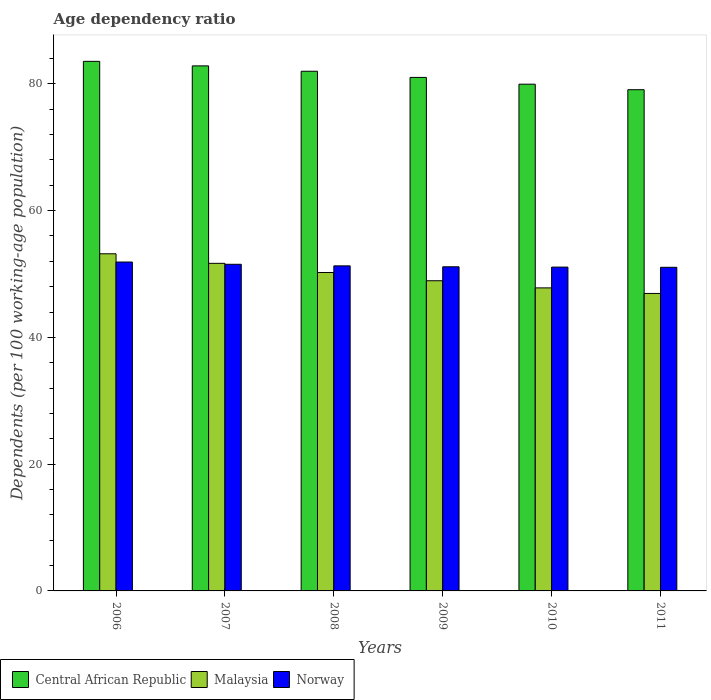How many groups of bars are there?
Keep it short and to the point. 6. Are the number of bars per tick equal to the number of legend labels?
Keep it short and to the point. Yes. Are the number of bars on each tick of the X-axis equal?
Your answer should be very brief. Yes. What is the label of the 3rd group of bars from the left?
Your answer should be very brief. 2008. In how many cases, is the number of bars for a given year not equal to the number of legend labels?
Ensure brevity in your answer.  0. What is the age dependency ratio in in Central African Republic in 2010?
Your answer should be very brief. 79.95. Across all years, what is the maximum age dependency ratio in in Central African Republic?
Ensure brevity in your answer.  83.55. Across all years, what is the minimum age dependency ratio in in Central African Republic?
Your answer should be compact. 79.08. In which year was the age dependency ratio in in Norway minimum?
Offer a terse response. 2011. What is the total age dependency ratio in in Norway in the graph?
Offer a very short reply. 307.99. What is the difference between the age dependency ratio in in Norway in 2009 and that in 2010?
Your answer should be compact. 0.05. What is the difference between the age dependency ratio in in Malaysia in 2007 and the age dependency ratio in in Central African Republic in 2006?
Ensure brevity in your answer.  -31.87. What is the average age dependency ratio in in Central African Republic per year?
Offer a very short reply. 81.4. In the year 2010, what is the difference between the age dependency ratio in in Central African Republic and age dependency ratio in in Malaysia?
Make the answer very short. 32.14. What is the ratio of the age dependency ratio in in Malaysia in 2009 to that in 2010?
Offer a very short reply. 1.02. Is the age dependency ratio in in Malaysia in 2006 less than that in 2010?
Offer a very short reply. No. Is the difference between the age dependency ratio in in Central African Republic in 2006 and 2008 greater than the difference between the age dependency ratio in in Malaysia in 2006 and 2008?
Ensure brevity in your answer.  No. What is the difference between the highest and the second highest age dependency ratio in in Malaysia?
Your answer should be very brief. 1.51. What is the difference between the highest and the lowest age dependency ratio in in Central African Republic?
Keep it short and to the point. 4.47. In how many years, is the age dependency ratio in in Malaysia greater than the average age dependency ratio in in Malaysia taken over all years?
Give a very brief answer. 3. Is the sum of the age dependency ratio in in Norway in 2007 and 2011 greater than the maximum age dependency ratio in in Central African Republic across all years?
Provide a succinct answer. Yes. What does the 3rd bar from the left in 2008 represents?
Give a very brief answer. Norway. What does the 2nd bar from the right in 2006 represents?
Ensure brevity in your answer.  Malaysia. How many bars are there?
Give a very brief answer. 18. How many years are there in the graph?
Keep it short and to the point. 6. What is the difference between two consecutive major ticks on the Y-axis?
Offer a very short reply. 20. Does the graph contain any zero values?
Offer a terse response. No. Does the graph contain grids?
Provide a succinct answer. No. How many legend labels are there?
Ensure brevity in your answer.  3. How are the legend labels stacked?
Your answer should be very brief. Horizontal. What is the title of the graph?
Offer a very short reply. Age dependency ratio. What is the label or title of the Y-axis?
Your response must be concise. Dependents (per 100 working-age population). What is the Dependents (per 100 working-age population) in Central African Republic in 2006?
Your answer should be compact. 83.55. What is the Dependents (per 100 working-age population) of Malaysia in 2006?
Ensure brevity in your answer.  53.19. What is the Dependents (per 100 working-age population) of Norway in 2006?
Your answer should be very brief. 51.89. What is the Dependents (per 100 working-age population) of Central African Republic in 2007?
Your response must be concise. 82.84. What is the Dependents (per 100 working-age population) in Malaysia in 2007?
Offer a terse response. 51.68. What is the Dependents (per 100 working-age population) in Norway in 2007?
Make the answer very short. 51.53. What is the Dependents (per 100 working-age population) in Central African Republic in 2008?
Your answer should be compact. 81.99. What is the Dependents (per 100 working-age population) of Malaysia in 2008?
Make the answer very short. 50.23. What is the Dependents (per 100 working-age population) of Norway in 2008?
Keep it short and to the point. 51.28. What is the Dependents (per 100 working-age population) of Central African Republic in 2009?
Offer a terse response. 81.02. What is the Dependents (per 100 working-age population) in Malaysia in 2009?
Keep it short and to the point. 48.94. What is the Dependents (per 100 working-age population) of Norway in 2009?
Offer a terse response. 51.14. What is the Dependents (per 100 working-age population) in Central African Republic in 2010?
Give a very brief answer. 79.95. What is the Dependents (per 100 working-age population) in Malaysia in 2010?
Provide a short and direct response. 47.81. What is the Dependents (per 100 working-age population) of Norway in 2010?
Offer a very short reply. 51.09. What is the Dependents (per 100 working-age population) in Central African Republic in 2011?
Give a very brief answer. 79.08. What is the Dependents (per 100 working-age population) of Malaysia in 2011?
Give a very brief answer. 46.93. What is the Dependents (per 100 working-age population) in Norway in 2011?
Give a very brief answer. 51.06. Across all years, what is the maximum Dependents (per 100 working-age population) in Central African Republic?
Offer a terse response. 83.55. Across all years, what is the maximum Dependents (per 100 working-age population) in Malaysia?
Provide a succinct answer. 53.19. Across all years, what is the maximum Dependents (per 100 working-age population) of Norway?
Make the answer very short. 51.89. Across all years, what is the minimum Dependents (per 100 working-age population) in Central African Republic?
Make the answer very short. 79.08. Across all years, what is the minimum Dependents (per 100 working-age population) in Malaysia?
Offer a terse response. 46.93. Across all years, what is the minimum Dependents (per 100 working-age population) in Norway?
Your response must be concise. 51.06. What is the total Dependents (per 100 working-age population) in Central African Republic in the graph?
Provide a short and direct response. 488.42. What is the total Dependents (per 100 working-age population) in Malaysia in the graph?
Ensure brevity in your answer.  298.79. What is the total Dependents (per 100 working-age population) of Norway in the graph?
Keep it short and to the point. 307.99. What is the difference between the Dependents (per 100 working-age population) in Central African Republic in 2006 and that in 2007?
Keep it short and to the point. 0.71. What is the difference between the Dependents (per 100 working-age population) in Malaysia in 2006 and that in 2007?
Make the answer very short. 1.51. What is the difference between the Dependents (per 100 working-age population) in Norway in 2006 and that in 2007?
Make the answer very short. 0.36. What is the difference between the Dependents (per 100 working-age population) in Central African Republic in 2006 and that in 2008?
Give a very brief answer. 1.56. What is the difference between the Dependents (per 100 working-age population) in Malaysia in 2006 and that in 2008?
Provide a short and direct response. 2.96. What is the difference between the Dependents (per 100 working-age population) in Norway in 2006 and that in 2008?
Make the answer very short. 0.61. What is the difference between the Dependents (per 100 working-age population) in Central African Republic in 2006 and that in 2009?
Your answer should be compact. 2.53. What is the difference between the Dependents (per 100 working-age population) in Malaysia in 2006 and that in 2009?
Your answer should be compact. 4.25. What is the difference between the Dependents (per 100 working-age population) in Norway in 2006 and that in 2009?
Make the answer very short. 0.75. What is the difference between the Dependents (per 100 working-age population) in Central African Republic in 2006 and that in 2010?
Provide a succinct answer. 3.6. What is the difference between the Dependents (per 100 working-age population) of Malaysia in 2006 and that in 2010?
Your response must be concise. 5.38. What is the difference between the Dependents (per 100 working-age population) in Norway in 2006 and that in 2010?
Ensure brevity in your answer.  0.8. What is the difference between the Dependents (per 100 working-age population) in Central African Republic in 2006 and that in 2011?
Offer a terse response. 4.47. What is the difference between the Dependents (per 100 working-age population) in Malaysia in 2006 and that in 2011?
Give a very brief answer. 6.26. What is the difference between the Dependents (per 100 working-age population) in Norway in 2006 and that in 2011?
Give a very brief answer. 0.83. What is the difference between the Dependents (per 100 working-age population) in Central African Republic in 2007 and that in 2008?
Your response must be concise. 0.85. What is the difference between the Dependents (per 100 working-age population) of Malaysia in 2007 and that in 2008?
Offer a terse response. 1.45. What is the difference between the Dependents (per 100 working-age population) of Norway in 2007 and that in 2008?
Your response must be concise. 0.25. What is the difference between the Dependents (per 100 working-age population) in Central African Republic in 2007 and that in 2009?
Ensure brevity in your answer.  1.82. What is the difference between the Dependents (per 100 working-age population) in Malaysia in 2007 and that in 2009?
Provide a short and direct response. 2.75. What is the difference between the Dependents (per 100 working-age population) in Norway in 2007 and that in 2009?
Make the answer very short. 0.39. What is the difference between the Dependents (per 100 working-age population) in Central African Republic in 2007 and that in 2010?
Your answer should be compact. 2.89. What is the difference between the Dependents (per 100 working-age population) of Malaysia in 2007 and that in 2010?
Your response must be concise. 3.87. What is the difference between the Dependents (per 100 working-age population) of Norway in 2007 and that in 2010?
Offer a terse response. 0.44. What is the difference between the Dependents (per 100 working-age population) in Central African Republic in 2007 and that in 2011?
Provide a succinct answer. 3.76. What is the difference between the Dependents (per 100 working-age population) in Malaysia in 2007 and that in 2011?
Provide a succinct answer. 4.75. What is the difference between the Dependents (per 100 working-age population) in Norway in 2007 and that in 2011?
Provide a succinct answer. 0.48. What is the difference between the Dependents (per 100 working-age population) of Central African Republic in 2008 and that in 2009?
Your answer should be very brief. 0.97. What is the difference between the Dependents (per 100 working-age population) of Malaysia in 2008 and that in 2009?
Ensure brevity in your answer.  1.3. What is the difference between the Dependents (per 100 working-age population) of Norway in 2008 and that in 2009?
Ensure brevity in your answer.  0.15. What is the difference between the Dependents (per 100 working-age population) in Central African Republic in 2008 and that in 2010?
Provide a succinct answer. 2.04. What is the difference between the Dependents (per 100 working-age population) in Malaysia in 2008 and that in 2010?
Give a very brief answer. 2.42. What is the difference between the Dependents (per 100 working-age population) of Norway in 2008 and that in 2010?
Your answer should be very brief. 0.19. What is the difference between the Dependents (per 100 working-age population) of Central African Republic in 2008 and that in 2011?
Make the answer very short. 2.91. What is the difference between the Dependents (per 100 working-age population) of Malaysia in 2008 and that in 2011?
Your answer should be compact. 3.3. What is the difference between the Dependents (per 100 working-age population) of Norway in 2008 and that in 2011?
Provide a succinct answer. 0.23. What is the difference between the Dependents (per 100 working-age population) of Central African Republic in 2009 and that in 2010?
Provide a succinct answer. 1.07. What is the difference between the Dependents (per 100 working-age population) of Malaysia in 2009 and that in 2010?
Give a very brief answer. 1.13. What is the difference between the Dependents (per 100 working-age population) in Norway in 2009 and that in 2010?
Offer a very short reply. 0.05. What is the difference between the Dependents (per 100 working-age population) of Central African Republic in 2009 and that in 2011?
Provide a short and direct response. 1.94. What is the difference between the Dependents (per 100 working-age population) in Malaysia in 2009 and that in 2011?
Provide a succinct answer. 2. What is the difference between the Dependents (per 100 working-age population) in Norway in 2009 and that in 2011?
Give a very brief answer. 0.08. What is the difference between the Dependents (per 100 working-age population) of Central African Republic in 2010 and that in 2011?
Provide a succinct answer. 0.87. What is the difference between the Dependents (per 100 working-age population) in Malaysia in 2010 and that in 2011?
Keep it short and to the point. 0.88. What is the difference between the Dependents (per 100 working-age population) in Norway in 2010 and that in 2011?
Ensure brevity in your answer.  0.03. What is the difference between the Dependents (per 100 working-age population) in Central African Republic in 2006 and the Dependents (per 100 working-age population) in Malaysia in 2007?
Give a very brief answer. 31.87. What is the difference between the Dependents (per 100 working-age population) of Central African Republic in 2006 and the Dependents (per 100 working-age population) of Norway in 2007?
Provide a succinct answer. 32.02. What is the difference between the Dependents (per 100 working-age population) in Malaysia in 2006 and the Dependents (per 100 working-age population) in Norway in 2007?
Provide a succinct answer. 1.66. What is the difference between the Dependents (per 100 working-age population) of Central African Republic in 2006 and the Dependents (per 100 working-age population) of Malaysia in 2008?
Your answer should be compact. 33.32. What is the difference between the Dependents (per 100 working-age population) of Central African Republic in 2006 and the Dependents (per 100 working-age population) of Norway in 2008?
Ensure brevity in your answer.  32.27. What is the difference between the Dependents (per 100 working-age population) in Malaysia in 2006 and the Dependents (per 100 working-age population) in Norway in 2008?
Make the answer very short. 1.91. What is the difference between the Dependents (per 100 working-age population) in Central African Republic in 2006 and the Dependents (per 100 working-age population) in Malaysia in 2009?
Ensure brevity in your answer.  34.61. What is the difference between the Dependents (per 100 working-age population) in Central African Republic in 2006 and the Dependents (per 100 working-age population) in Norway in 2009?
Your answer should be compact. 32.41. What is the difference between the Dependents (per 100 working-age population) of Malaysia in 2006 and the Dependents (per 100 working-age population) of Norway in 2009?
Make the answer very short. 2.05. What is the difference between the Dependents (per 100 working-age population) of Central African Republic in 2006 and the Dependents (per 100 working-age population) of Malaysia in 2010?
Ensure brevity in your answer.  35.74. What is the difference between the Dependents (per 100 working-age population) of Central African Republic in 2006 and the Dependents (per 100 working-age population) of Norway in 2010?
Your answer should be very brief. 32.46. What is the difference between the Dependents (per 100 working-age population) in Malaysia in 2006 and the Dependents (per 100 working-age population) in Norway in 2010?
Make the answer very short. 2.1. What is the difference between the Dependents (per 100 working-age population) in Central African Republic in 2006 and the Dependents (per 100 working-age population) in Malaysia in 2011?
Keep it short and to the point. 36.62. What is the difference between the Dependents (per 100 working-age population) in Central African Republic in 2006 and the Dependents (per 100 working-age population) in Norway in 2011?
Give a very brief answer. 32.49. What is the difference between the Dependents (per 100 working-age population) of Malaysia in 2006 and the Dependents (per 100 working-age population) of Norway in 2011?
Provide a succinct answer. 2.13. What is the difference between the Dependents (per 100 working-age population) in Central African Republic in 2007 and the Dependents (per 100 working-age population) in Malaysia in 2008?
Ensure brevity in your answer.  32.6. What is the difference between the Dependents (per 100 working-age population) of Central African Republic in 2007 and the Dependents (per 100 working-age population) of Norway in 2008?
Offer a very short reply. 31.55. What is the difference between the Dependents (per 100 working-age population) of Malaysia in 2007 and the Dependents (per 100 working-age population) of Norway in 2008?
Provide a succinct answer. 0.4. What is the difference between the Dependents (per 100 working-age population) in Central African Republic in 2007 and the Dependents (per 100 working-age population) in Malaysia in 2009?
Ensure brevity in your answer.  33.9. What is the difference between the Dependents (per 100 working-age population) of Central African Republic in 2007 and the Dependents (per 100 working-age population) of Norway in 2009?
Make the answer very short. 31.7. What is the difference between the Dependents (per 100 working-age population) of Malaysia in 2007 and the Dependents (per 100 working-age population) of Norway in 2009?
Offer a very short reply. 0.55. What is the difference between the Dependents (per 100 working-age population) of Central African Republic in 2007 and the Dependents (per 100 working-age population) of Malaysia in 2010?
Your response must be concise. 35.03. What is the difference between the Dependents (per 100 working-age population) of Central African Republic in 2007 and the Dependents (per 100 working-age population) of Norway in 2010?
Provide a short and direct response. 31.75. What is the difference between the Dependents (per 100 working-age population) in Malaysia in 2007 and the Dependents (per 100 working-age population) in Norway in 2010?
Keep it short and to the point. 0.59. What is the difference between the Dependents (per 100 working-age population) in Central African Republic in 2007 and the Dependents (per 100 working-age population) in Malaysia in 2011?
Make the answer very short. 35.9. What is the difference between the Dependents (per 100 working-age population) in Central African Republic in 2007 and the Dependents (per 100 working-age population) in Norway in 2011?
Offer a very short reply. 31.78. What is the difference between the Dependents (per 100 working-age population) in Malaysia in 2007 and the Dependents (per 100 working-age population) in Norway in 2011?
Your answer should be very brief. 0.63. What is the difference between the Dependents (per 100 working-age population) of Central African Republic in 2008 and the Dependents (per 100 working-age population) of Malaysia in 2009?
Give a very brief answer. 33.05. What is the difference between the Dependents (per 100 working-age population) in Central African Republic in 2008 and the Dependents (per 100 working-age population) in Norway in 2009?
Provide a short and direct response. 30.85. What is the difference between the Dependents (per 100 working-age population) in Malaysia in 2008 and the Dependents (per 100 working-age population) in Norway in 2009?
Your response must be concise. -0.9. What is the difference between the Dependents (per 100 working-age population) in Central African Republic in 2008 and the Dependents (per 100 working-age population) in Malaysia in 2010?
Provide a short and direct response. 34.18. What is the difference between the Dependents (per 100 working-age population) of Central African Republic in 2008 and the Dependents (per 100 working-age population) of Norway in 2010?
Provide a succinct answer. 30.9. What is the difference between the Dependents (per 100 working-age population) in Malaysia in 2008 and the Dependents (per 100 working-age population) in Norway in 2010?
Offer a very short reply. -0.86. What is the difference between the Dependents (per 100 working-age population) in Central African Republic in 2008 and the Dependents (per 100 working-age population) in Malaysia in 2011?
Give a very brief answer. 35.06. What is the difference between the Dependents (per 100 working-age population) of Central African Republic in 2008 and the Dependents (per 100 working-age population) of Norway in 2011?
Your answer should be very brief. 30.93. What is the difference between the Dependents (per 100 working-age population) in Malaysia in 2008 and the Dependents (per 100 working-age population) in Norway in 2011?
Your answer should be compact. -0.82. What is the difference between the Dependents (per 100 working-age population) in Central African Republic in 2009 and the Dependents (per 100 working-age population) in Malaysia in 2010?
Keep it short and to the point. 33.21. What is the difference between the Dependents (per 100 working-age population) in Central African Republic in 2009 and the Dependents (per 100 working-age population) in Norway in 2010?
Give a very brief answer. 29.93. What is the difference between the Dependents (per 100 working-age population) of Malaysia in 2009 and the Dependents (per 100 working-age population) of Norway in 2010?
Provide a succinct answer. -2.15. What is the difference between the Dependents (per 100 working-age population) in Central African Republic in 2009 and the Dependents (per 100 working-age population) in Malaysia in 2011?
Keep it short and to the point. 34.08. What is the difference between the Dependents (per 100 working-age population) of Central African Republic in 2009 and the Dependents (per 100 working-age population) of Norway in 2011?
Offer a very short reply. 29.96. What is the difference between the Dependents (per 100 working-age population) in Malaysia in 2009 and the Dependents (per 100 working-age population) in Norway in 2011?
Provide a succinct answer. -2.12. What is the difference between the Dependents (per 100 working-age population) in Central African Republic in 2010 and the Dependents (per 100 working-age population) in Malaysia in 2011?
Provide a short and direct response. 33.02. What is the difference between the Dependents (per 100 working-age population) of Central African Republic in 2010 and the Dependents (per 100 working-age population) of Norway in 2011?
Ensure brevity in your answer.  28.89. What is the difference between the Dependents (per 100 working-age population) in Malaysia in 2010 and the Dependents (per 100 working-age population) in Norway in 2011?
Ensure brevity in your answer.  -3.25. What is the average Dependents (per 100 working-age population) of Central African Republic per year?
Give a very brief answer. 81.4. What is the average Dependents (per 100 working-age population) in Malaysia per year?
Your answer should be compact. 49.8. What is the average Dependents (per 100 working-age population) in Norway per year?
Keep it short and to the point. 51.33. In the year 2006, what is the difference between the Dependents (per 100 working-age population) of Central African Republic and Dependents (per 100 working-age population) of Malaysia?
Your answer should be compact. 30.36. In the year 2006, what is the difference between the Dependents (per 100 working-age population) of Central African Republic and Dependents (per 100 working-age population) of Norway?
Provide a succinct answer. 31.66. In the year 2006, what is the difference between the Dependents (per 100 working-age population) in Malaysia and Dependents (per 100 working-age population) in Norway?
Provide a short and direct response. 1.3. In the year 2007, what is the difference between the Dependents (per 100 working-age population) in Central African Republic and Dependents (per 100 working-age population) in Malaysia?
Provide a short and direct response. 31.15. In the year 2007, what is the difference between the Dependents (per 100 working-age population) of Central African Republic and Dependents (per 100 working-age population) of Norway?
Provide a succinct answer. 31.3. In the year 2007, what is the difference between the Dependents (per 100 working-age population) of Malaysia and Dependents (per 100 working-age population) of Norway?
Provide a succinct answer. 0.15. In the year 2008, what is the difference between the Dependents (per 100 working-age population) in Central African Republic and Dependents (per 100 working-age population) in Malaysia?
Offer a terse response. 31.75. In the year 2008, what is the difference between the Dependents (per 100 working-age population) of Central African Republic and Dependents (per 100 working-age population) of Norway?
Keep it short and to the point. 30.7. In the year 2008, what is the difference between the Dependents (per 100 working-age population) in Malaysia and Dependents (per 100 working-age population) in Norway?
Ensure brevity in your answer.  -1.05. In the year 2009, what is the difference between the Dependents (per 100 working-age population) of Central African Republic and Dependents (per 100 working-age population) of Malaysia?
Ensure brevity in your answer.  32.08. In the year 2009, what is the difference between the Dependents (per 100 working-age population) in Central African Republic and Dependents (per 100 working-age population) in Norway?
Your answer should be very brief. 29.88. In the year 2009, what is the difference between the Dependents (per 100 working-age population) in Malaysia and Dependents (per 100 working-age population) in Norway?
Ensure brevity in your answer.  -2.2. In the year 2010, what is the difference between the Dependents (per 100 working-age population) of Central African Republic and Dependents (per 100 working-age population) of Malaysia?
Keep it short and to the point. 32.14. In the year 2010, what is the difference between the Dependents (per 100 working-age population) in Central African Republic and Dependents (per 100 working-age population) in Norway?
Give a very brief answer. 28.86. In the year 2010, what is the difference between the Dependents (per 100 working-age population) of Malaysia and Dependents (per 100 working-age population) of Norway?
Ensure brevity in your answer.  -3.28. In the year 2011, what is the difference between the Dependents (per 100 working-age population) of Central African Republic and Dependents (per 100 working-age population) of Malaysia?
Your response must be concise. 32.14. In the year 2011, what is the difference between the Dependents (per 100 working-age population) of Central African Republic and Dependents (per 100 working-age population) of Norway?
Make the answer very short. 28.02. In the year 2011, what is the difference between the Dependents (per 100 working-age population) of Malaysia and Dependents (per 100 working-age population) of Norway?
Give a very brief answer. -4.12. What is the ratio of the Dependents (per 100 working-age population) in Central African Republic in 2006 to that in 2007?
Your response must be concise. 1.01. What is the ratio of the Dependents (per 100 working-age population) of Malaysia in 2006 to that in 2007?
Offer a terse response. 1.03. What is the ratio of the Dependents (per 100 working-age population) of Norway in 2006 to that in 2007?
Your answer should be compact. 1.01. What is the ratio of the Dependents (per 100 working-age population) of Central African Republic in 2006 to that in 2008?
Give a very brief answer. 1.02. What is the ratio of the Dependents (per 100 working-age population) in Malaysia in 2006 to that in 2008?
Offer a very short reply. 1.06. What is the ratio of the Dependents (per 100 working-age population) of Norway in 2006 to that in 2008?
Provide a short and direct response. 1.01. What is the ratio of the Dependents (per 100 working-age population) of Central African Republic in 2006 to that in 2009?
Provide a succinct answer. 1.03. What is the ratio of the Dependents (per 100 working-age population) of Malaysia in 2006 to that in 2009?
Your answer should be very brief. 1.09. What is the ratio of the Dependents (per 100 working-age population) of Norway in 2006 to that in 2009?
Offer a terse response. 1.01. What is the ratio of the Dependents (per 100 working-age population) in Central African Republic in 2006 to that in 2010?
Offer a terse response. 1.04. What is the ratio of the Dependents (per 100 working-age population) in Malaysia in 2006 to that in 2010?
Make the answer very short. 1.11. What is the ratio of the Dependents (per 100 working-age population) of Norway in 2006 to that in 2010?
Offer a very short reply. 1.02. What is the ratio of the Dependents (per 100 working-age population) of Central African Republic in 2006 to that in 2011?
Provide a short and direct response. 1.06. What is the ratio of the Dependents (per 100 working-age population) of Malaysia in 2006 to that in 2011?
Your answer should be very brief. 1.13. What is the ratio of the Dependents (per 100 working-age population) in Norway in 2006 to that in 2011?
Provide a succinct answer. 1.02. What is the ratio of the Dependents (per 100 working-age population) in Central African Republic in 2007 to that in 2008?
Provide a short and direct response. 1.01. What is the ratio of the Dependents (per 100 working-age population) of Malaysia in 2007 to that in 2008?
Provide a succinct answer. 1.03. What is the ratio of the Dependents (per 100 working-age population) in Central African Republic in 2007 to that in 2009?
Provide a short and direct response. 1.02. What is the ratio of the Dependents (per 100 working-age population) of Malaysia in 2007 to that in 2009?
Your answer should be very brief. 1.06. What is the ratio of the Dependents (per 100 working-age population) in Norway in 2007 to that in 2009?
Provide a succinct answer. 1.01. What is the ratio of the Dependents (per 100 working-age population) in Central African Republic in 2007 to that in 2010?
Your response must be concise. 1.04. What is the ratio of the Dependents (per 100 working-age population) in Malaysia in 2007 to that in 2010?
Give a very brief answer. 1.08. What is the ratio of the Dependents (per 100 working-age population) in Norway in 2007 to that in 2010?
Ensure brevity in your answer.  1.01. What is the ratio of the Dependents (per 100 working-age population) of Central African Republic in 2007 to that in 2011?
Your answer should be compact. 1.05. What is the ratio of the Dependents (per 100 working-age population) in Malaysia in 2007 to that in 2011?
Offer a very short reply. 1.1. What is the ratio of the Dependents (per 100 working-age population) of Norway in 2007 to that in 2011?
Give a very brief answer. 1.01. What is the ratio of the Dependents (per 100 working-age population) in Malaysia in 2008 to that in 2009?
Keep it short and to the point. 1.03. What is the ratio of the Dependents (per 100 working-age population) of Central African Republic in 2008 to that in 2010?
Your answer should be compact. 1.03. What is the ratio of the Dependents (per 100 working-age population) in Malaysia in 2008 to that in 2010?
Your answer should be compact. 1.05. What is the ratio of the Dependents (per 100 working-age population) of Norway in 2008 to that in 2010?
Your answer should be very brief. 1. What is the ratio of the Dependents (per 100 working-age population) in Central African Republic in 2008 to that in 2011?
Offer a very short reply. 1.04. What is the ratio of the Dependents (per 100 working-age population) in Malaysia in 2008 to that in 2011?
Provide a short and direct response. 1.07. What is the ratio of the Dependents (per 100 working-age population) in Norway in 2008 to that in 2011?
Your answer should be compact. 1. What is the ratio of the Dependents (per 100 working-age population) in Central African Republic in 2009 to that in 2010?
Provide a succinct answer. 1.01. What is the ratio of the Dependents (per 100 working-age population) in Malaysia in 2009 to that in 2010?
Ensure brevity in your answer.  1.02. What is the ratio of the Dependents (per 100 working-age population) in Norway in 2009 to that in 2010?
Offer a terse response. 1. What is the ratio of the Dependents (per 100 working-age population) of Central African Republic in 2009 to that in 2011?
Your answer should be compact. 1.02. What is the ratio of the Dependents (per 100 working-age population) of Malaysia in 2009 to that in 2011?
Provide a succinct answer. 1.04. What is the ratio of the Dependents (per 100 working-age population) of Malaysia in 2010 to that in 2011?
Your answer should be very brief. 1.02. What is the ratio of the Dependents (per 100 working-age population) of Norway in 2010 to that in 2011?
Provide a succinct answer. 1. What is the difference between the highest and the second highest Dependents (per 100 working-age population) of Central African Republic?
Ensure brevity in your answer.  0.71. What is the difference between the highest and the second highest Dependents (per 100 working-age population) in Malaysia?
Provide a succinct answer. 1.51. What is the difference between the highest and the second highest Dependents (per 100 working-age population) in Norway?
Make the answer very short. 0.36. What is the difference between the highest and the lowest Dependents (per 100 working-age population) in Central African Republic?
Offer a very short reply. 4.47. What is the difference between the highest and the lowest Dependents (per 100 working-age population) in Malaysia?
Provide a succinct answer. 6.26. What is the difference between the highest and the lowest Dependents (per 100 working-age population) of Norway?
Your answer should be compact. 0.83. 